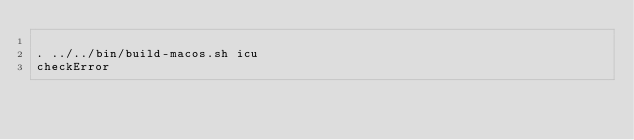<code> <loc_0><loc_0><loc_500><loc_500><_Bash_>
. ../../bin/build-macos.sh icu
checkError

</code> 